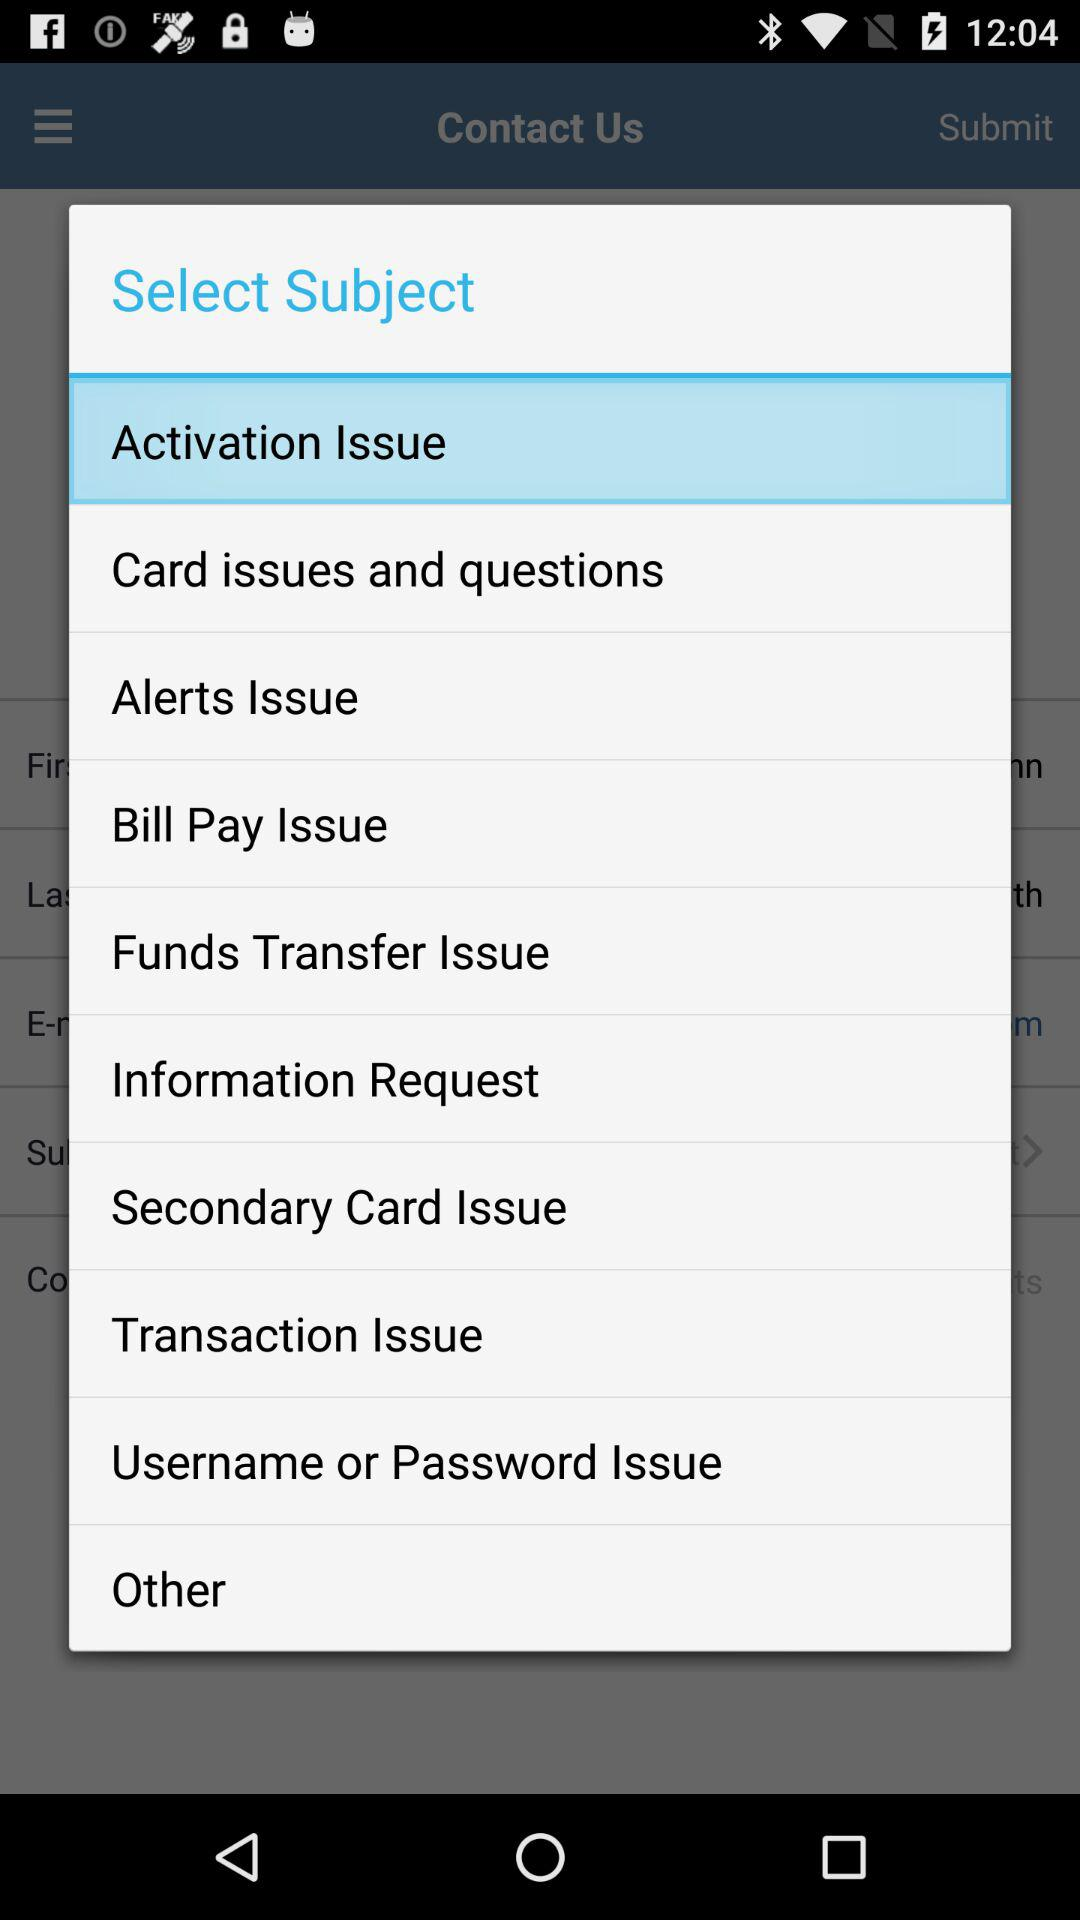Which is the selected subject? The selected subject is "Activation Issue". 